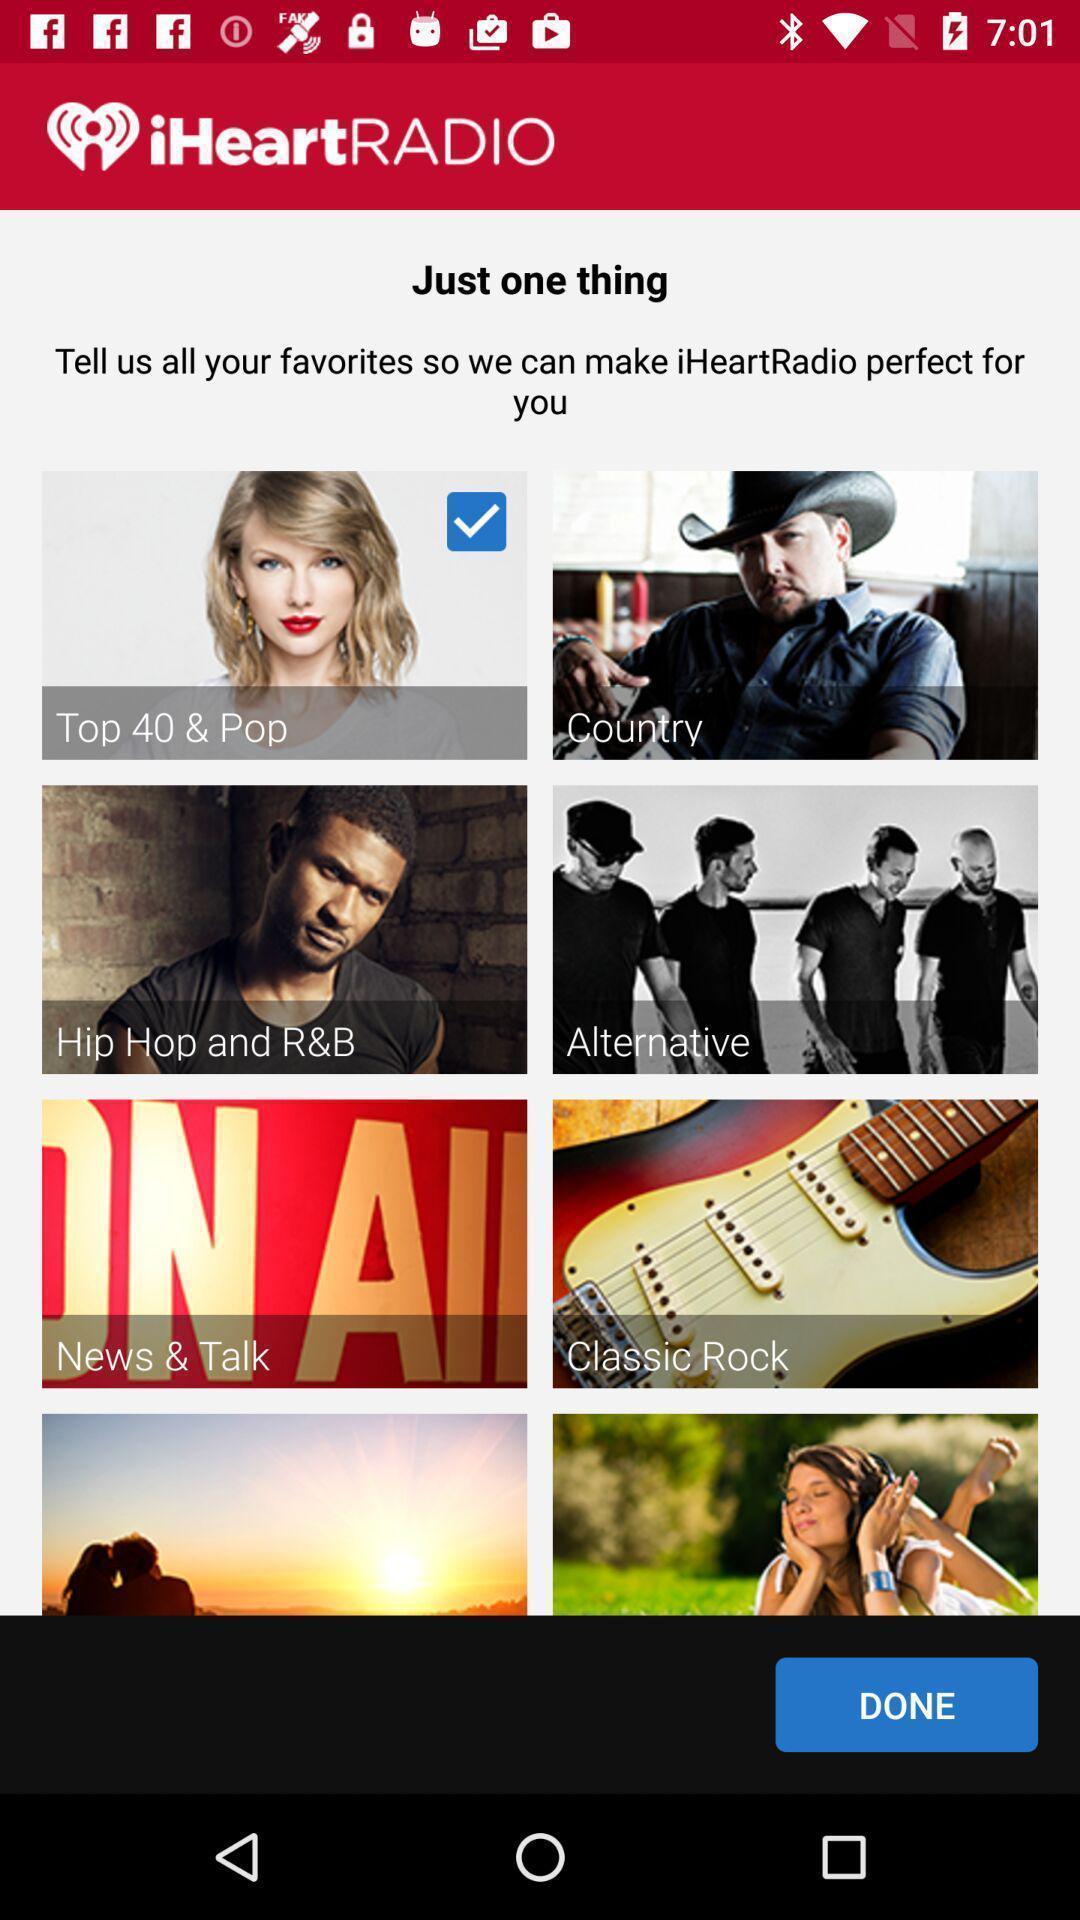Summarize the information in this screenshot. Playlists page of a radio app. 